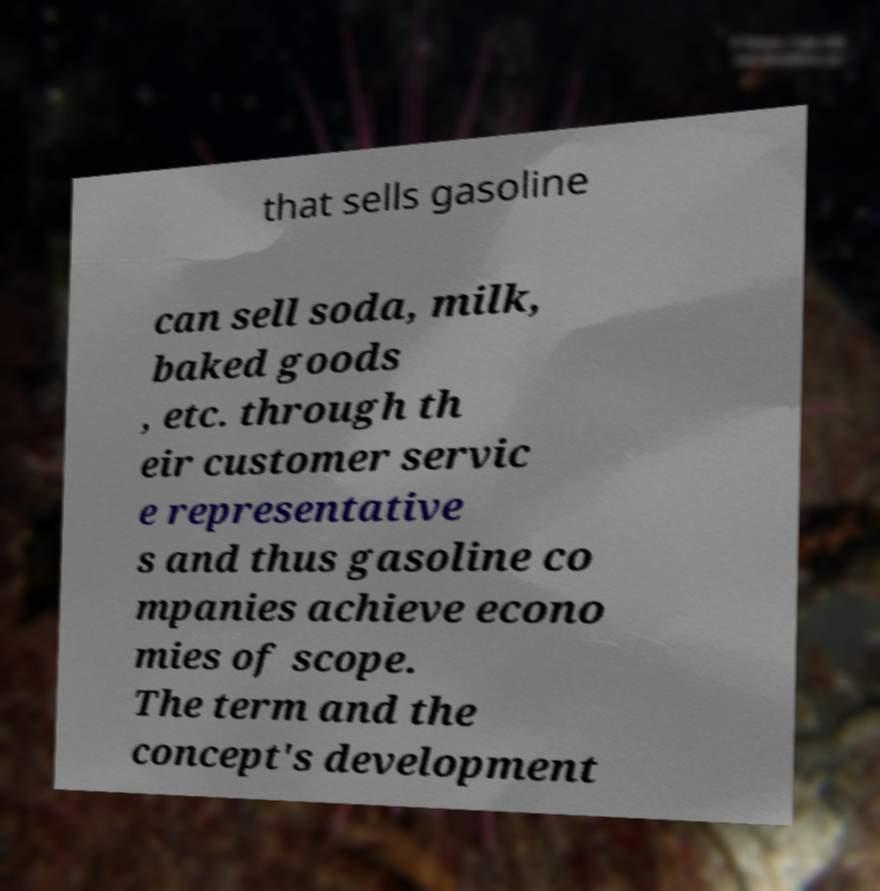Can you accurately transcribe the text from the provided image for me? that sells gasoline can sell soda, milk, baked goods , etc. through th eir customer servic e representative s and thus gasoline co mpanies achieve econo mies of scope. The term and the concept's development 